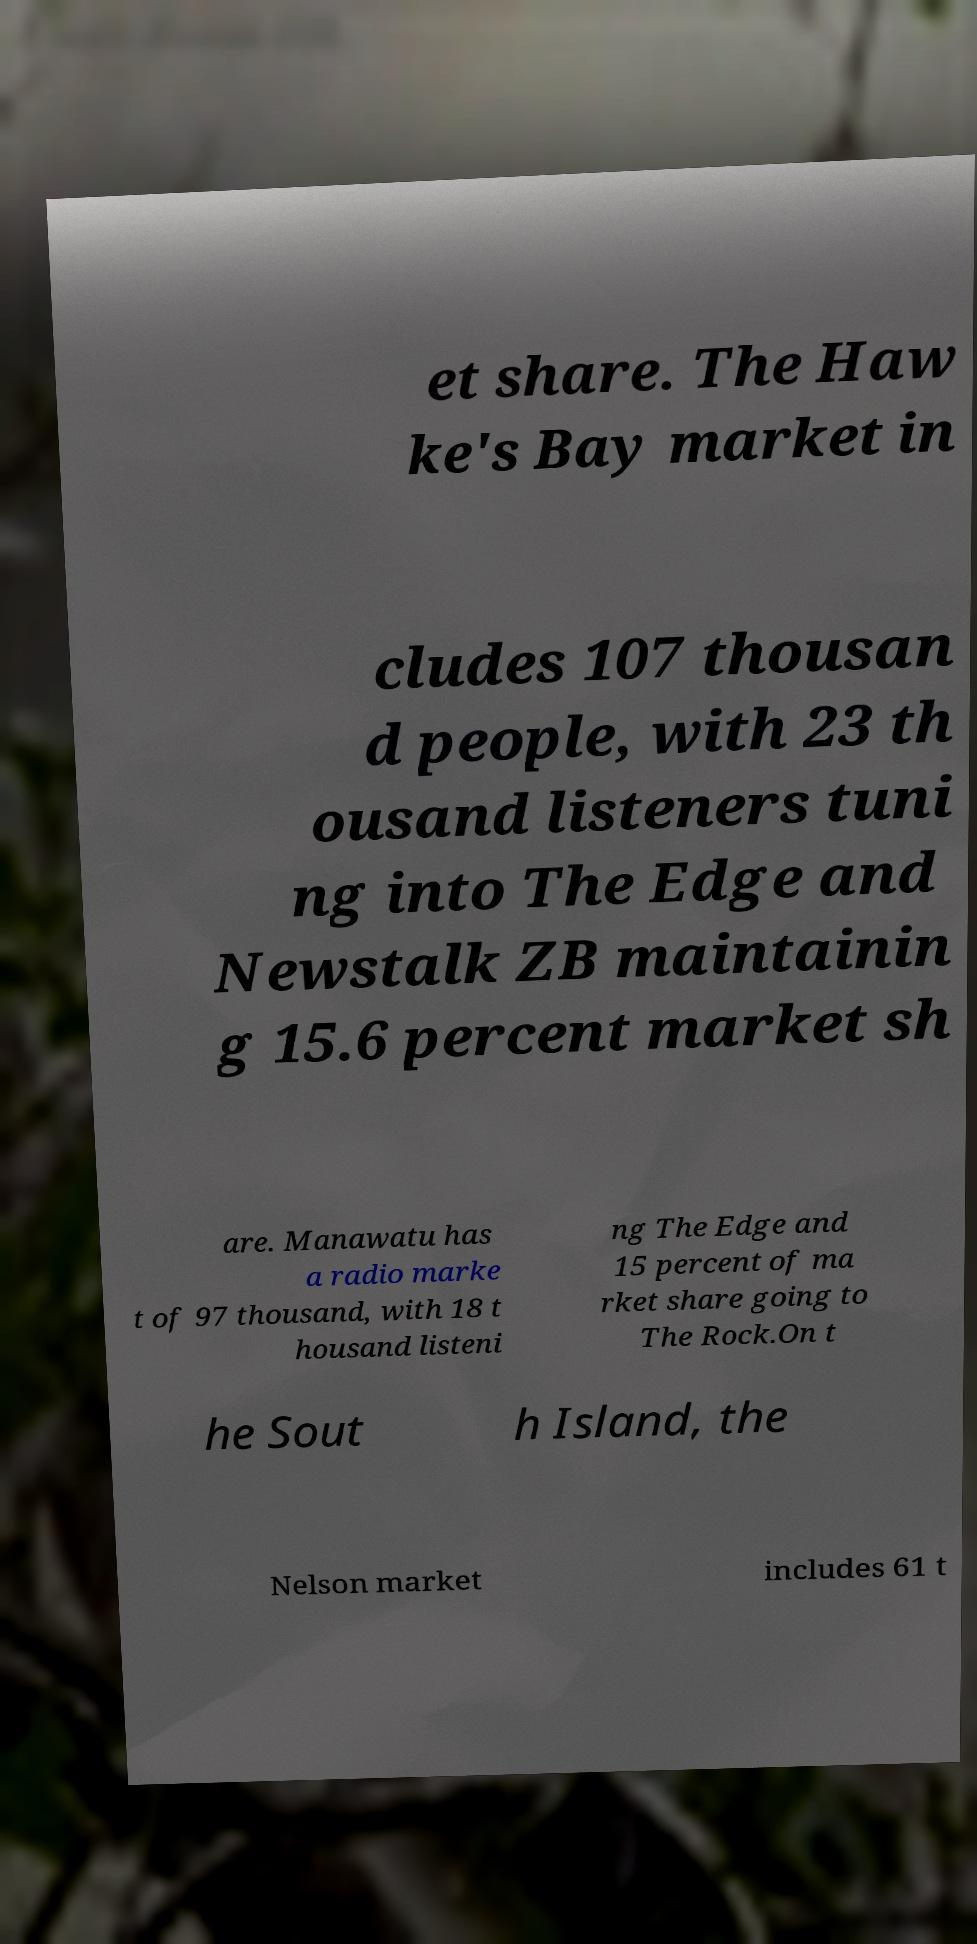Please identify and transcribe the text found in this image. et share. The Haw ke's Bay market in cludes 107 thousan d people, with 23 th ousand listeners tuni ng into The Edge and Newstalk ZB maintainin g 15.6 percent market sh are. Manawatu has a radio marke t of 97 thousand, with 18 t housand listeni ng The Edge and 15 percent of ma rket share going to The Rock.On t he Sout h Island, the Nelson market includes 61 t 